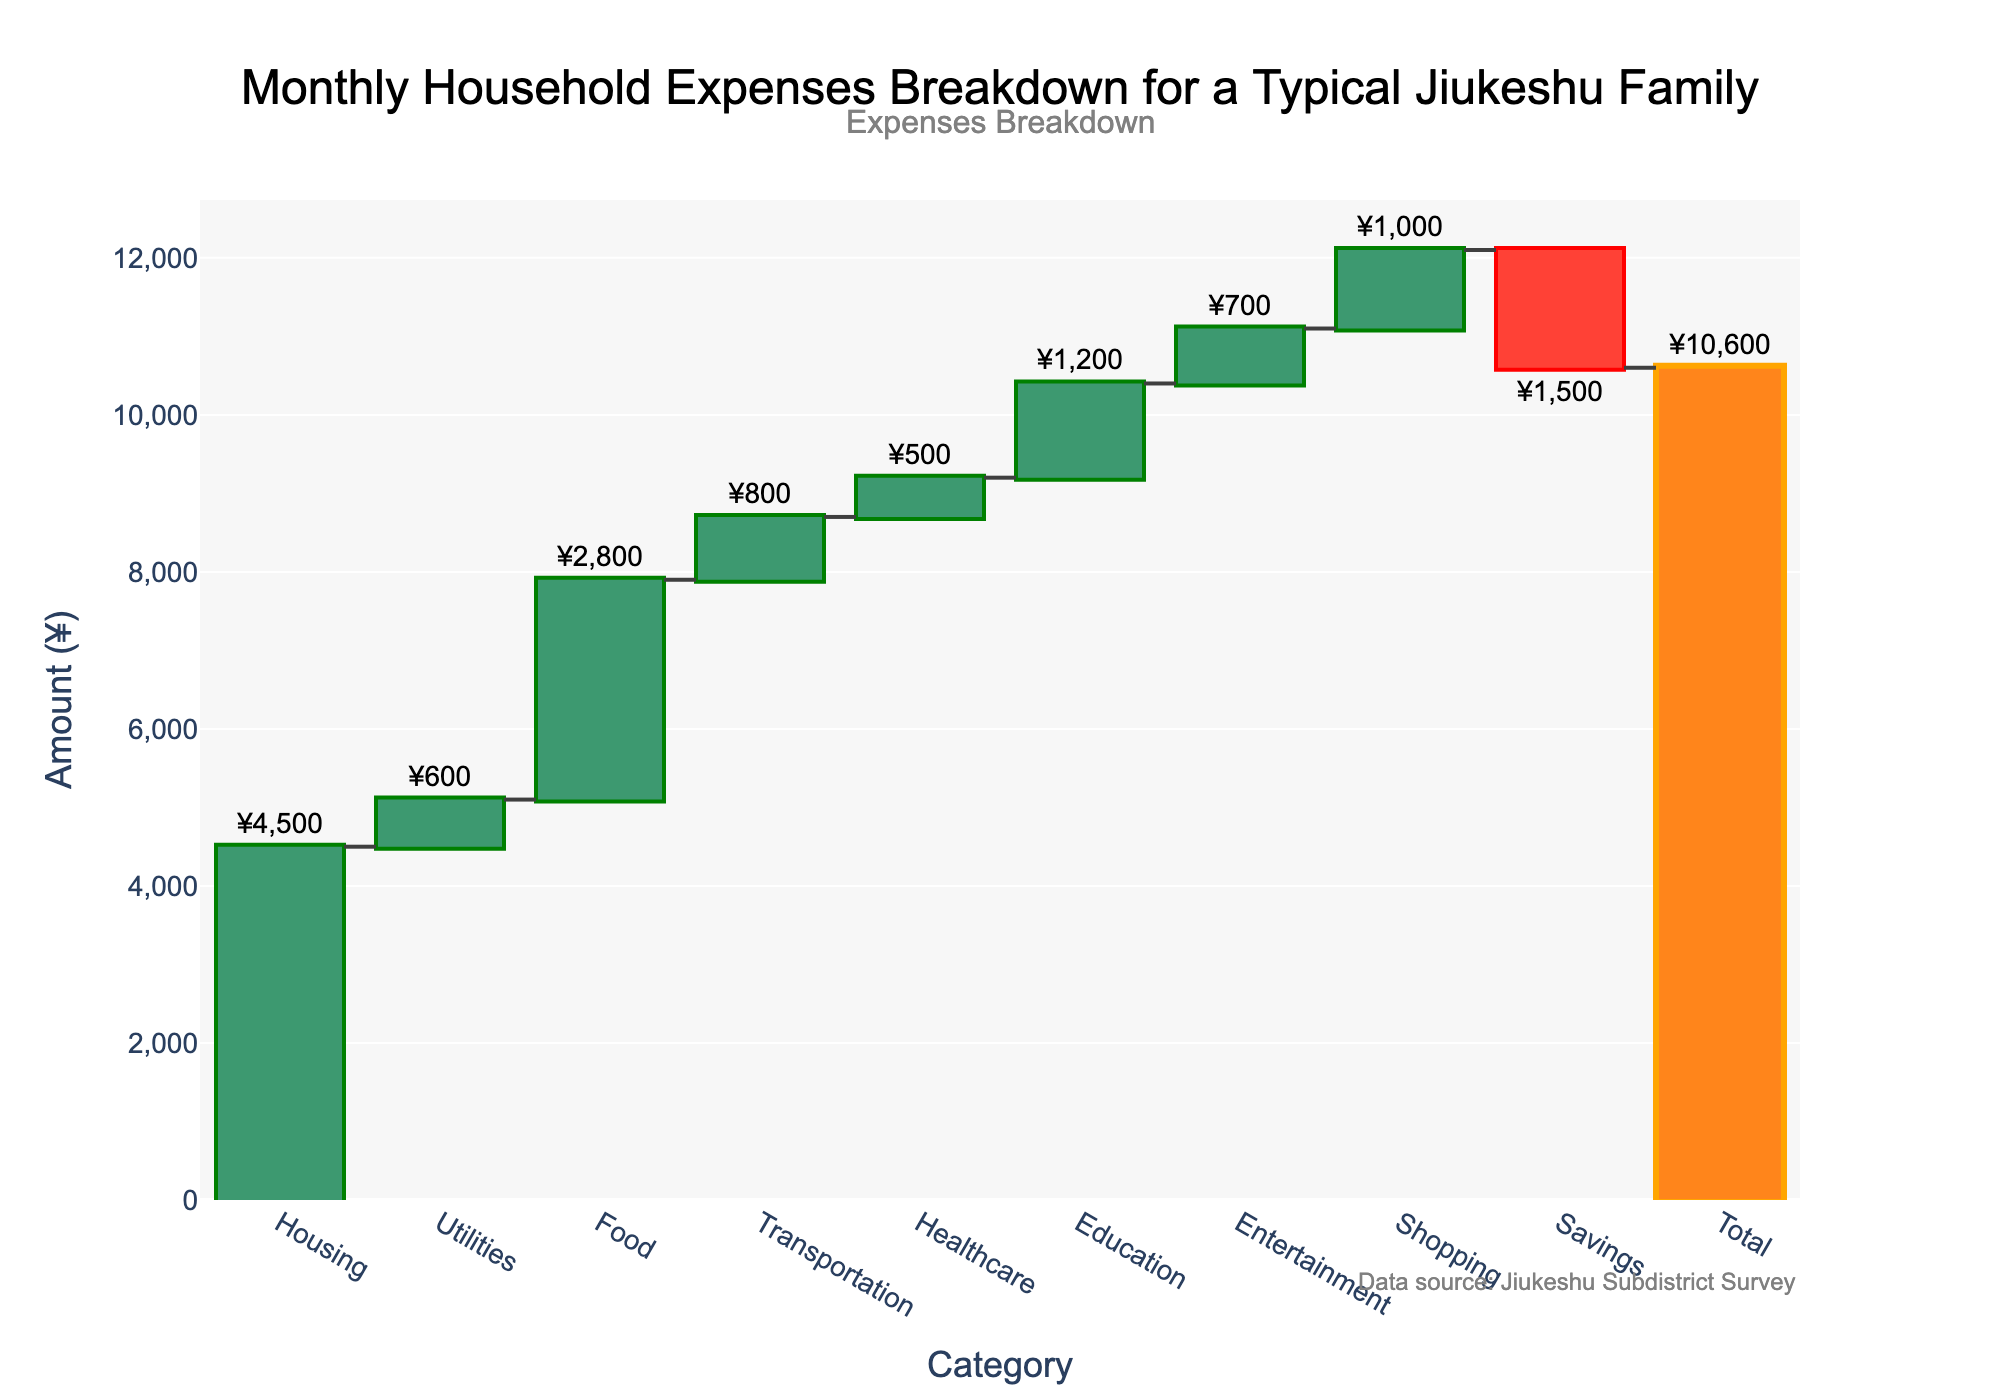What's the title of the figure? The title is typically displayed at the top of the figure and describes the overall theme or subject of the chart. In this case, it is centered and formatted clearly.
Answer: Monthly Household Expenses Breakdown for a Typical Jiukeshu Family How much does the typical Jiukeshu family spend on food each month? The amount spent on food is represented by one of the bars in the waterfall chart. By identifying the bar labeled 'Food,' you can see the precise amount written on or near it.
Answer: ¥2,800 What is the total monthly expenditure for a typical Jiukeshu family? The total monthly expenditure is shown at the end of the waterfall chart and is represented by the 'Total' bar, which accumulates all other expenses.
Answer: ¥10,600 Which category has the highest expense? By examining the lengths of the bars, the category with the longest bar represents the highest expense. The key to identify categories by color also helps determine this.
Answer: Housing By how much do savings reduce the total expenses? The bar labeled 'Savings' shows a negative value indicating a reduction in the total expenses. By reading the value associated with this bar, you can find out the amount by which savings reduce expenses.
Answer: ¥1,500 What are the expenses categories that contribute to the total amount? The expenses categories are listed along the x-axis. Observing all the labels from left to right reveals the contributing categories.
Answer: Housing, Utilities, Food, Transportation, Healthcare, Education, Entertainment, Shopping How much more is spent on housing compared to transportation? To find the difference, look at the amounts associated with both 'Housing' and 'Transportation.' Subtract the transportation amount from the housing amount.
Answer: ¥4,500 - ¥800 = ¥3,700 What's the average expense across all categories (excluding the total and savings)? To calculate the average, sum up all the expenses for the categories listed (excluding savings and total) and divide by the number of those categories.
Answer: (4500 + 600 + 2800 + 800 + 500 + 1200 + 700 + 1000) / 8 = ¥1,637.50 Which expense category contributes the least to the total expenses? Identify the bar with the shortest length that does not represent savings or total. Check the label to determine the corresponding expense category.
Answer: Healthcare What is the combined amount spent on utilities and education? Add the amounts for 'Utilities' and 'Education' together to find the combined expense for these two categories.
Answer: ¥600 + ¥1,200 = ¥1,800 